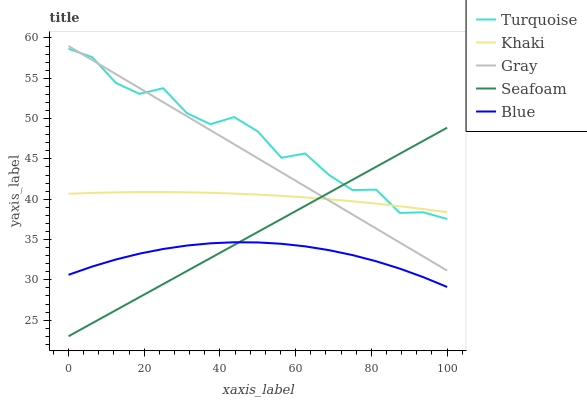Does Gray have the minimum area under the curve?
Answer yes or no. No. Does Gray have the maximum area under the curve?
Answer yes or no. No. Is Gray the smoothest?
Answer yes or no. No. Is Gray the roughest?
Answer yes or no. No. Does Gray have the lowest value?
Answer yes or no. No. Does Turquoise have the highest value?
Answer yes or no. No. Is Blue less than Gray?
Answer yes or no. Yes. Is Turquoise greater than Blue?
Answer yes or no. Yes. Does Blue intersect Gray?
Answer yes or no. No. 